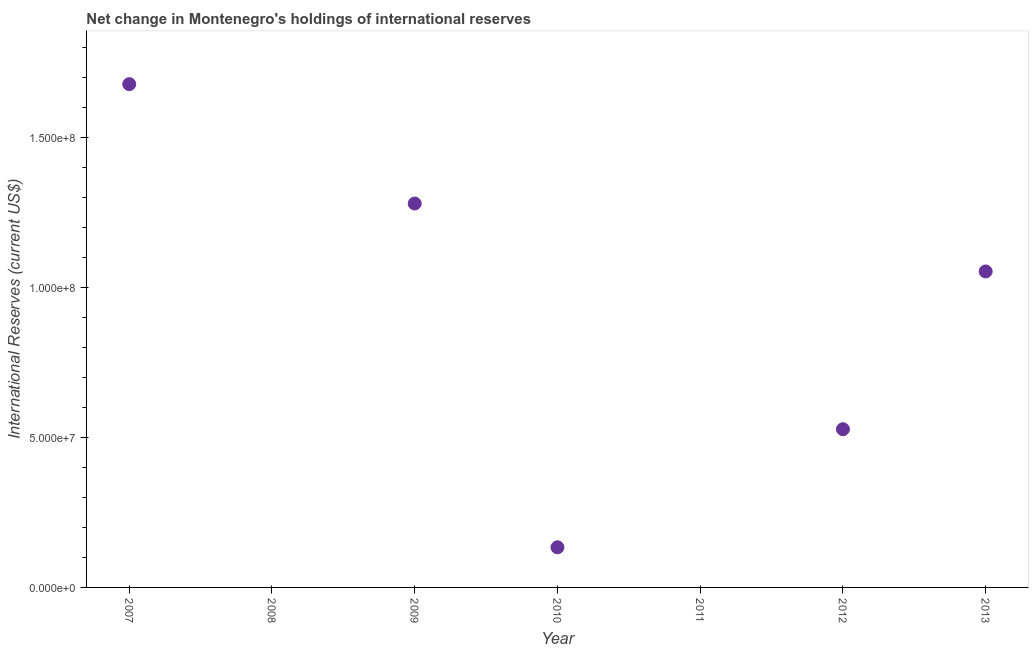What is the reserves and related items in 2012?
Keep it short and to the point. 5.27e+07. Across all years, what is the maximum reserves and related items?
Keep it short and to the point. 1.68e+08. Across all years, what is the minimum reserves and related items?
Make the answer very short. 0. What is the sum of the reserves and related items?
Your response must be concise. 4.67e+08. What is the difference between the reserves and related items in 2010 and 2013?
Offer a terse response. -9.19e+07. What is the average reserves and related items per year?
Ensure brevity in your answer.  6.67e+07. What is the median reserves and related items?
Your response must be concise. 5.27e+07. In how many years, is the reserves and related items greater than 130000000 US$?
Provide a short and direct response. 1. What is the ratio of the reserves and related items in 2007 to that in 2010?
Ensure brevity in your answer.  12.55. Is the reserves and related items in 2009 less than that in 2010?
Keep it short and to the point. No. What is the difference between the highest and the second highest reserves and related items?
Your answer should be very brief. 3.98e+07. Is the sum of the reserves and related items in 2009 and 2013 greater than the maximum reserves and related items across all years?
Give a very brief answer. Yes. What is the difference between the highest and the lowest reserves and related items?
Give a very brief answer. 1.68e+08. How many years are there in the graph?
Give a very brief answer. 7. Are the values on the major ticks of Y-axis written in scientific E-notation?
Provide a short and direct response. Yes. Does the graph contain any zero values?
Offer a very short reply. Yes. What is the title of the graph?
Your answer should be very brief. Net change in Montenegro's holdings of international reserves. What is the label or title of the X-axis?
Your response must be concise. Year. What is the label or title of the Y-axis?
Your answer should be compact. International Reserves (current US$). What is the International Reserves (current US$) in 2007?
Offer a terse response. 1.68e+08. What is the International Reserves (current US$) in 2009?
Ensure brevity in your answer.  1.28e+08. What is the International Reserves (current US$) in 2010?
Your answer should be very brief. 1.34e+07. What is the International Reserves (current US$) in 2012?
Make the answer very short. 5.27e+07. What is the International Reserves (current US$) in 2013?
Keep it short and to the point. 1.05e+08. What is the difference between the International Reserves (current US$) in 2007 and 2009?
Provide a short and direct response. 3.98e+07. What is the difference between the International Reserves (current US$) in 2007 and 2010?
Provide a short and direct response. 1.54e+08. What is the difference between the International Reserves (current US$) in 2007 and 2012?
Ensure brevity in your answer.  1.15e+08. What is the difference between the International Reserves (current US$) in 2007 and 2013?
Keep it short and to the point. 6.24e+07. What is the difference between the International Reserves (current US$) in 2009 and 2010?
Keep it short and to the point. 1.15e+08. What is the difference between the International Reserves (current US$) in 2009 and 2012?
Give a very brief answer. 7.52e+07. What is the difference between the International Reserves (current US$) in 2009 and 2013?
Provide a succinct answer. 2.26e+07. What is the difference between the International Reserves (current US$) in 2010 and 2012?
Ensure brevity in your answer.  -3.93e+07. What is the difference between the International Reserves (current US$) in 2010 and 2013?
Keep it short and to the point. -9.19e+07. What is the difference between the International Reserves (current US$) in 2012 and 2013?
Offer a terse response. -5.26e+07. What is the ratio of the International Reserves (current US$) in 2007 to that in 2009?
Provide a short and direct response. 1.31. What is the ratio of the International Reserves (current US$) in 2007 to that in 2010?
Provide a succinct answer. 12.55. What is the ratio of the International Reserves (current US$) in 2007 to that in 2012?
Offer a very short reply. 3.18. What is the ratio of the International Reserves (current US$) in 2007 to that in 2013?
Provide a succinct answer. 1.59. What is the ratio of the International Reserves (current US$) in 2009 to that in 2010?
Offer a terse response. 9.57. What is the ratio of the International Reserves (current US$) in 2009 to that in 2012?
Offer a very short reply. 2.43. What is the ratio of the International Reserves (current US$) in 2009 to that in 2013?
Ensure brevity in your answer.  1.22. What is the ratio of the International Reserves (current US$) in 2010 to that in 2012?
Keep it short and to the point. 0.25. What is the ratio of the International Reserves (current US$) in 2010 to that in 2013?
Your response must be concise. 0.13. What is the ratio of the International Reserves (current US$) in 2012 to that in 2013?
Make the answer very short. 0.5. 